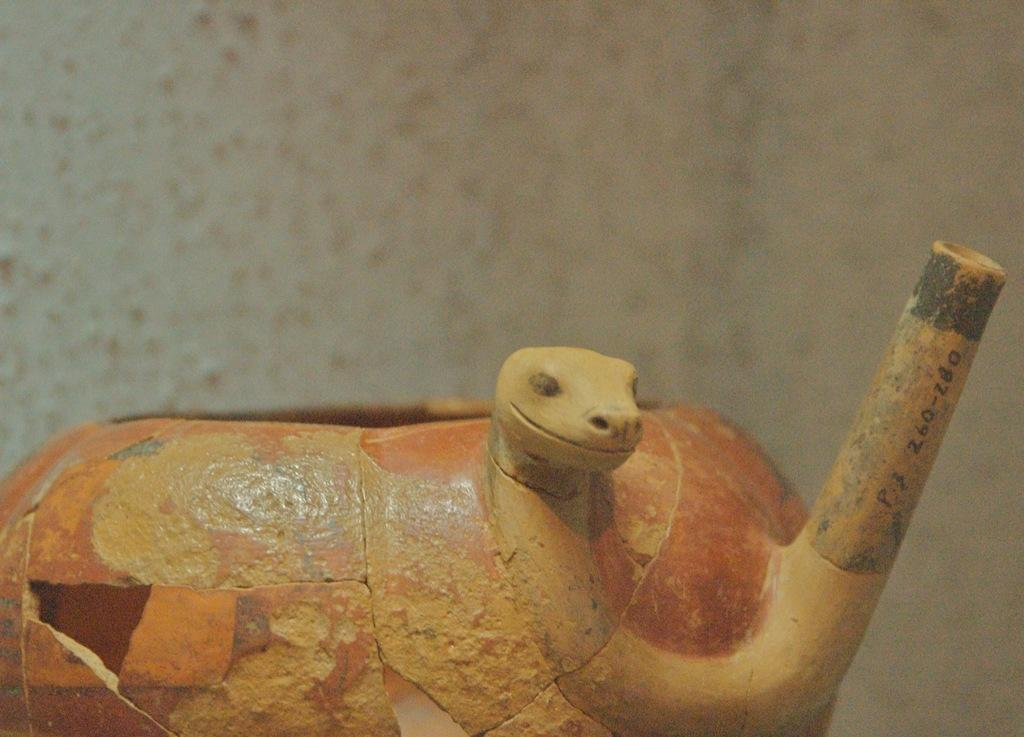What colors are present in the image? There is an object in the image that is yellow and another object that is orange. Can you describe the background of the image? The background of the image is blurred. How many cherries are on the rose in the image? There is no rose or cherries present in the image. What type of car can be seen driving through the yellow object in the image? There is no car present in the image, and the yellow object is not a road or path for a car to drive through. 